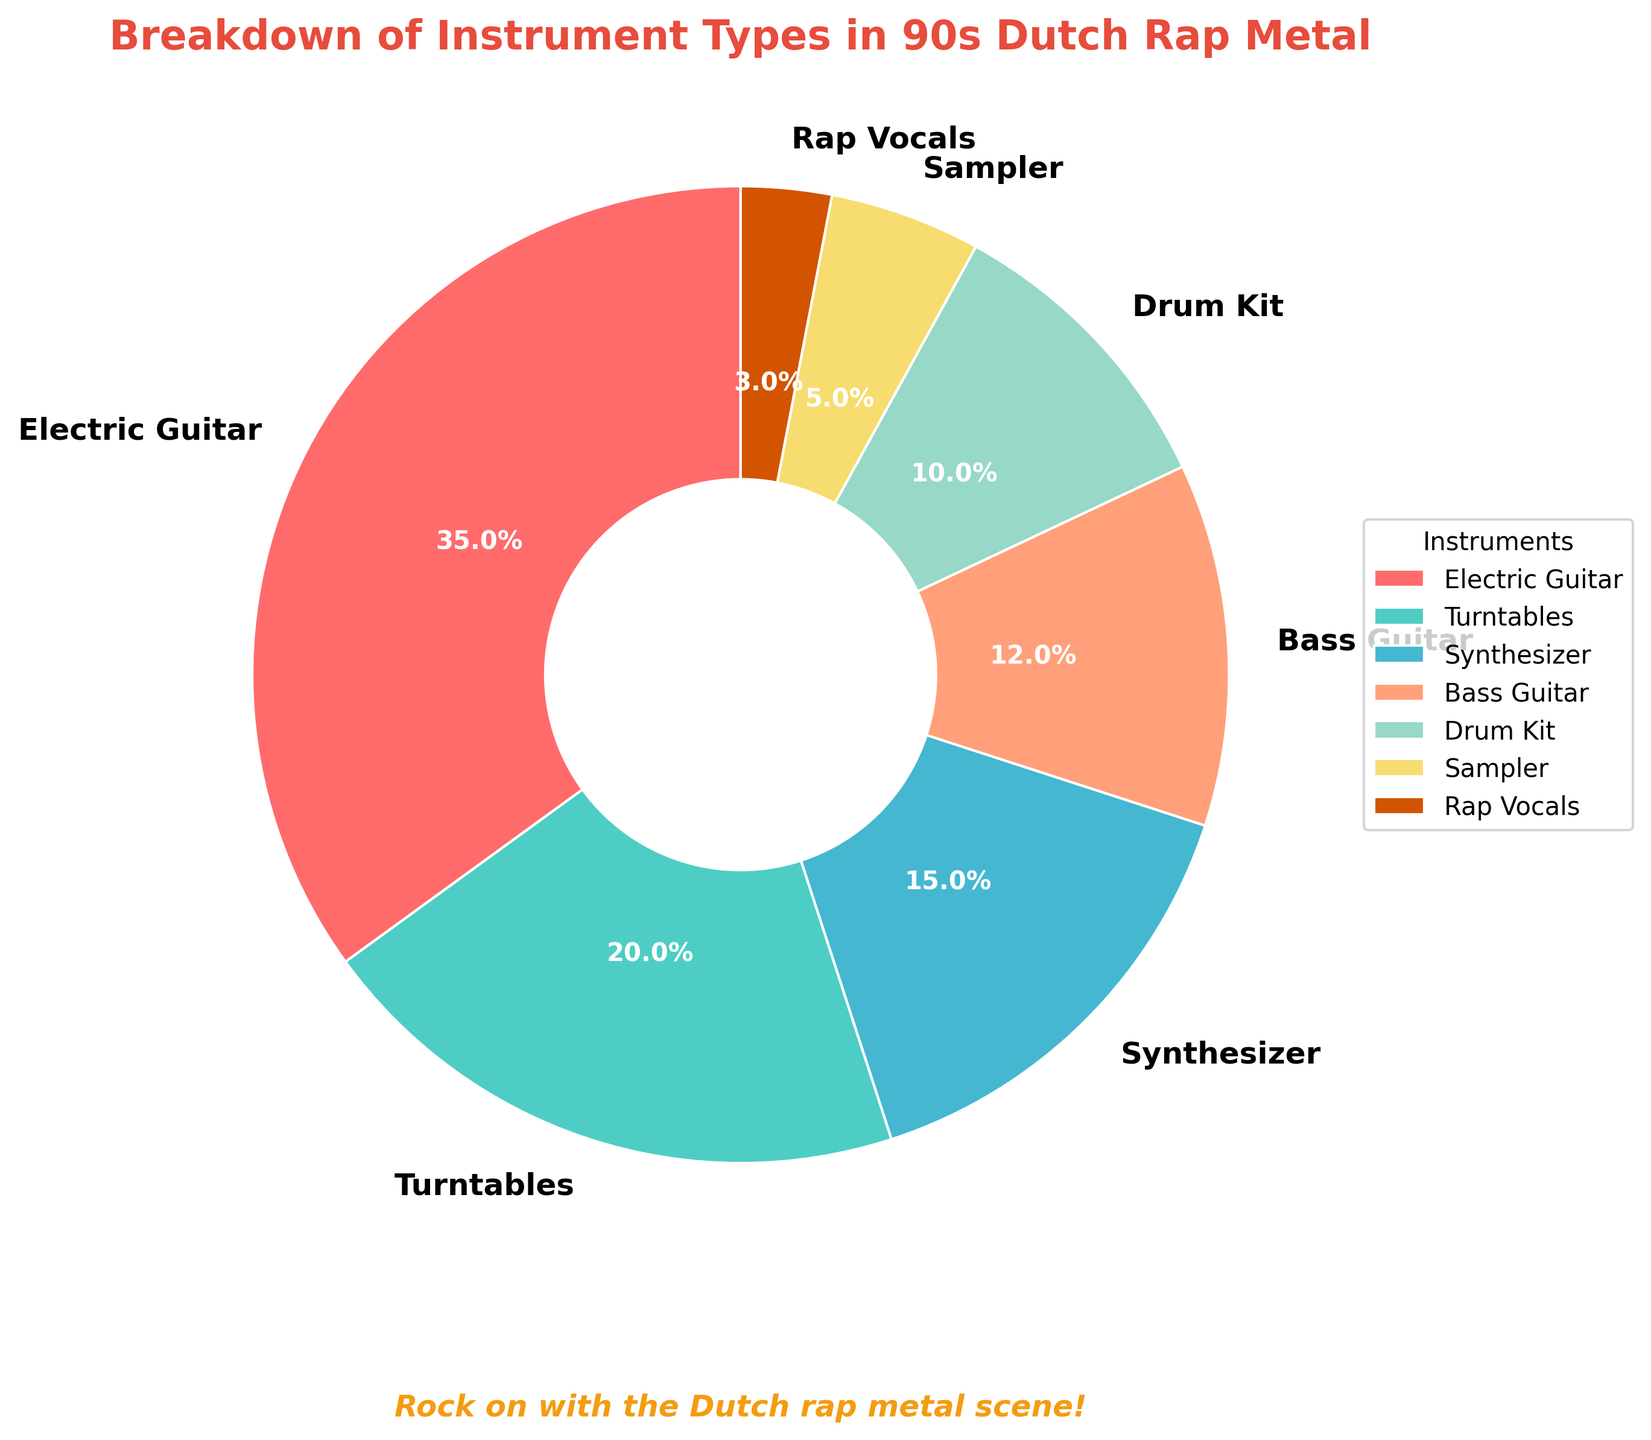What's the largest slice in the pie chart? The electric guitar slice is the largest in the pie chart, occupying 35% of the overall distribution.
Answer: Electric Guitar Which instrument types have percentages greater than 10%? By analyzing the pie chart, the instrument types with percentages greater than 10% are Electric Guitar (35%), Turntables (20%), Synthesizer (15%), and Bass Guitar (12%).
Answer: Electric Guitar, Turntables, Synthesizer, Bass Guitar Which has a higher percentage: Synthesizer or Drum Kit? Checking the values in the pie chart, Synthesizer has a higher percentage (15%) compared to the Drum Kit (10%).
Answer: Synthesizer How much more percentage does the Electric Guitar have compared to the Sampler? The Electric Guitar occupies 35% whereas the Sampler occupies 5%. The difference is calculated as 35% - 5% = 30%.
Answer: 30% What is the combined percentage for Turntables and Synthesizer? Adding the percentages for Turntables and Synthesizer gives 20% + 15% = 35%.
Answer: 35% Which slice has the smallest percentage in the pie chart? The smallest slice in the pie chart represents Rap Vocals, which has a percentage of 3%.
Answer: Rap Vocals Are the combined percentages of Bass Guitar and Drum Kit greater than that of Turntables? Bass Guitar is 12% and Drum Kit is 10%, combined they make 12% + 10% = 22%. Turntables are 20%. Since 22% is greater than 20%, the answer is yes.
Answer: Yes What visual attribute is used to differentiate each instrument type in the pie chart? The chart uses different colors to visually distinguish each instrument type. The colors range from reds to greens and blues, among others.
Answer: Colors Which instrument type, according to the pie chart, is less common than the Turntables but more common than Sampler? Synthesizer, with 15%, fits between Turntables (20%) and Sampler (5%) in the pie chart.
Answer: Synthesizer What percentage more of the pie chart does Electric Guitar occupy compared to Bass Guitar? The Electric Guitar occupies 35% and Bass Guitar occupies 12%. The difference in percentage is 35% - 12% = 23%.
Answer: 23% 